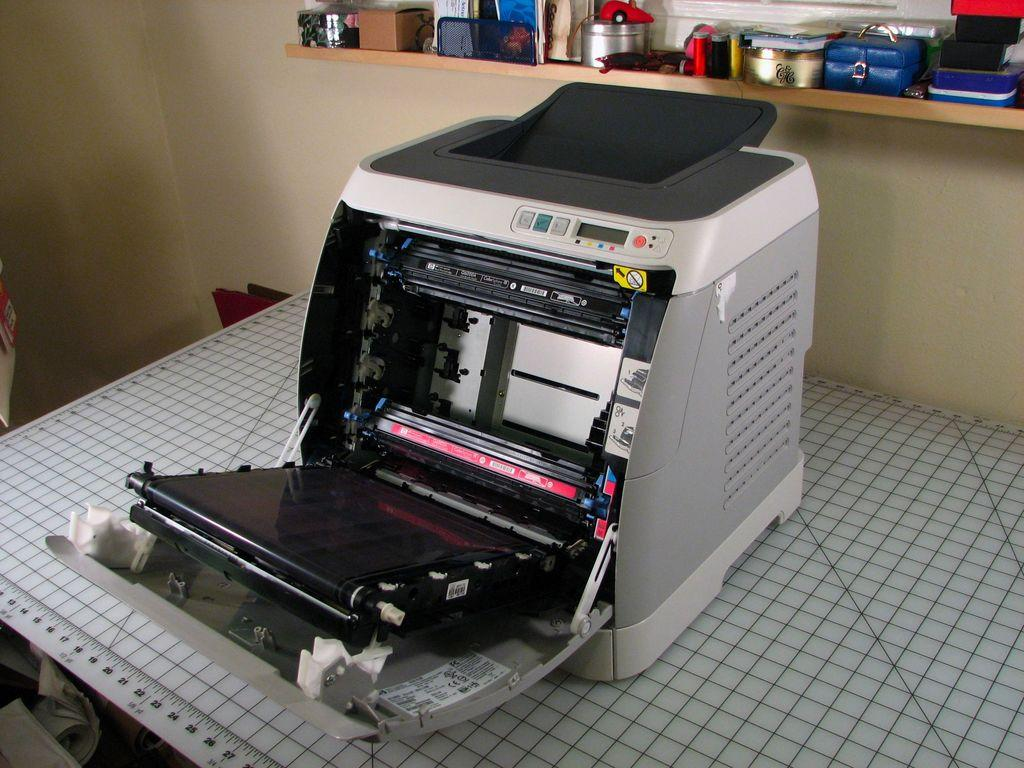What is the main object on the table in the image? There is a machine on a table in the image. What can be seen in the background of the image? There is a shelf attached to the wall in the background of the image. What is on the shelf in the background of the image? There are objects on the shelf in the background of the image. How many dogs are visible on the shelf in the image? There are no dogs present in the image; the shelf contains objects, not animals. 